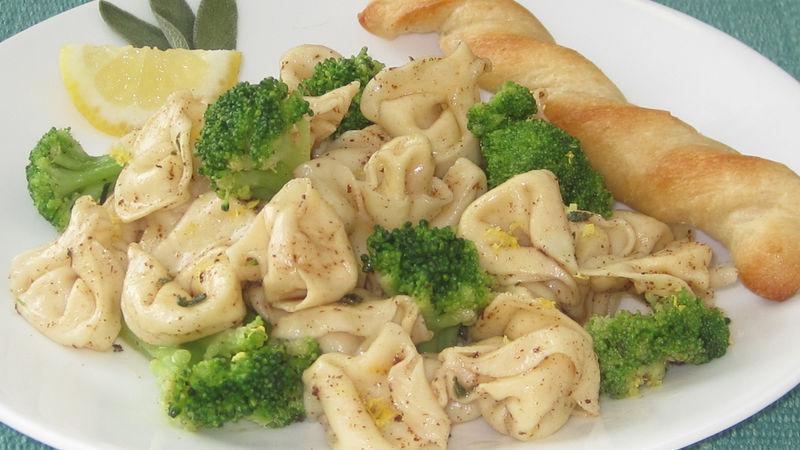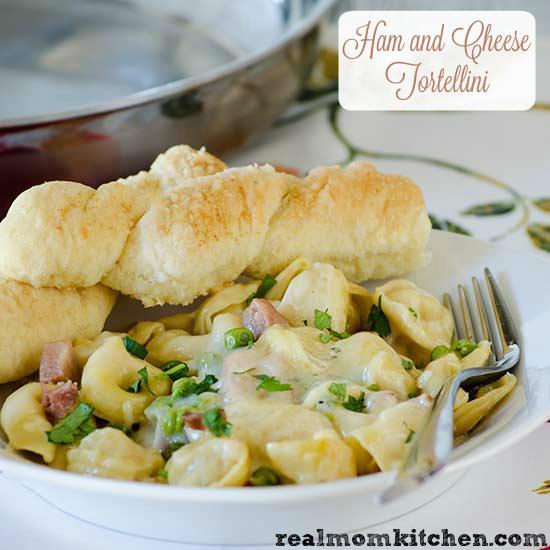The first image is the image on the left, the second image is the image on the right. For the images shown, is this caption "The right image contains a fork." true? Answer yes or no. Yes. The first image is the image on the left, the second image is the image on the right. Assess this claim about the two images: "All broccoli dishes are served on white plates.". Correct or not? Answer yes or no. Yes. 